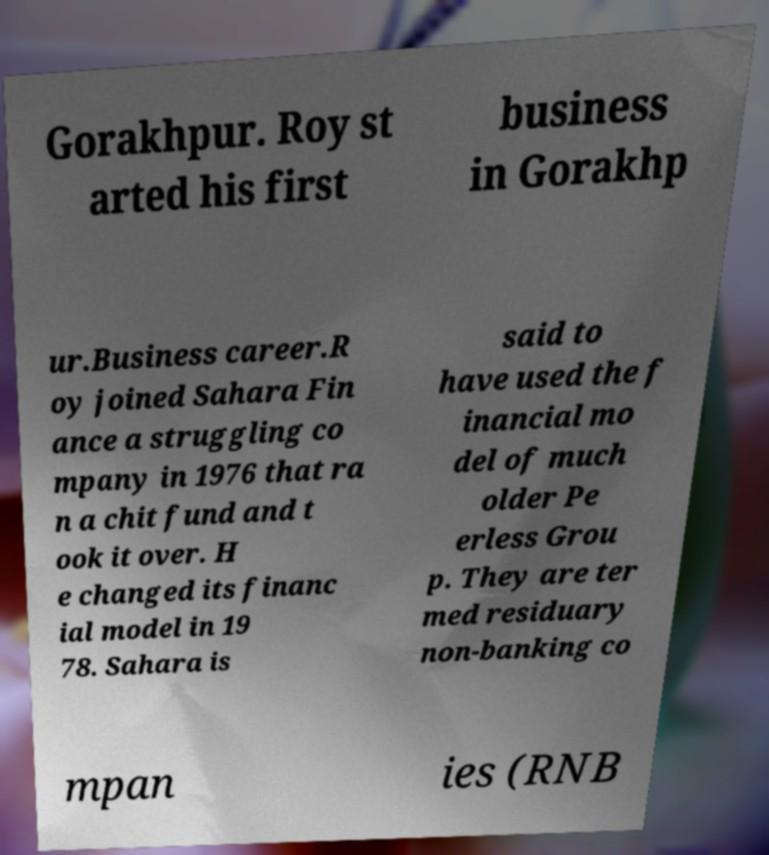Please read and relay the text visible in this image. What does it say? Gorakhpur. Roy st arted his first business in Gorakhp ur.Business career.R oy joined Sahara Fin ance a struggling co mpany in 1976 that ra n a chit fund and t ook it over. H e changed its financ ial model in 19 78. Sahara is said to have used the f inancial mo del of much older Pe erless Grou p. They are ter med residuary non-banking co mpan ies (RNB 